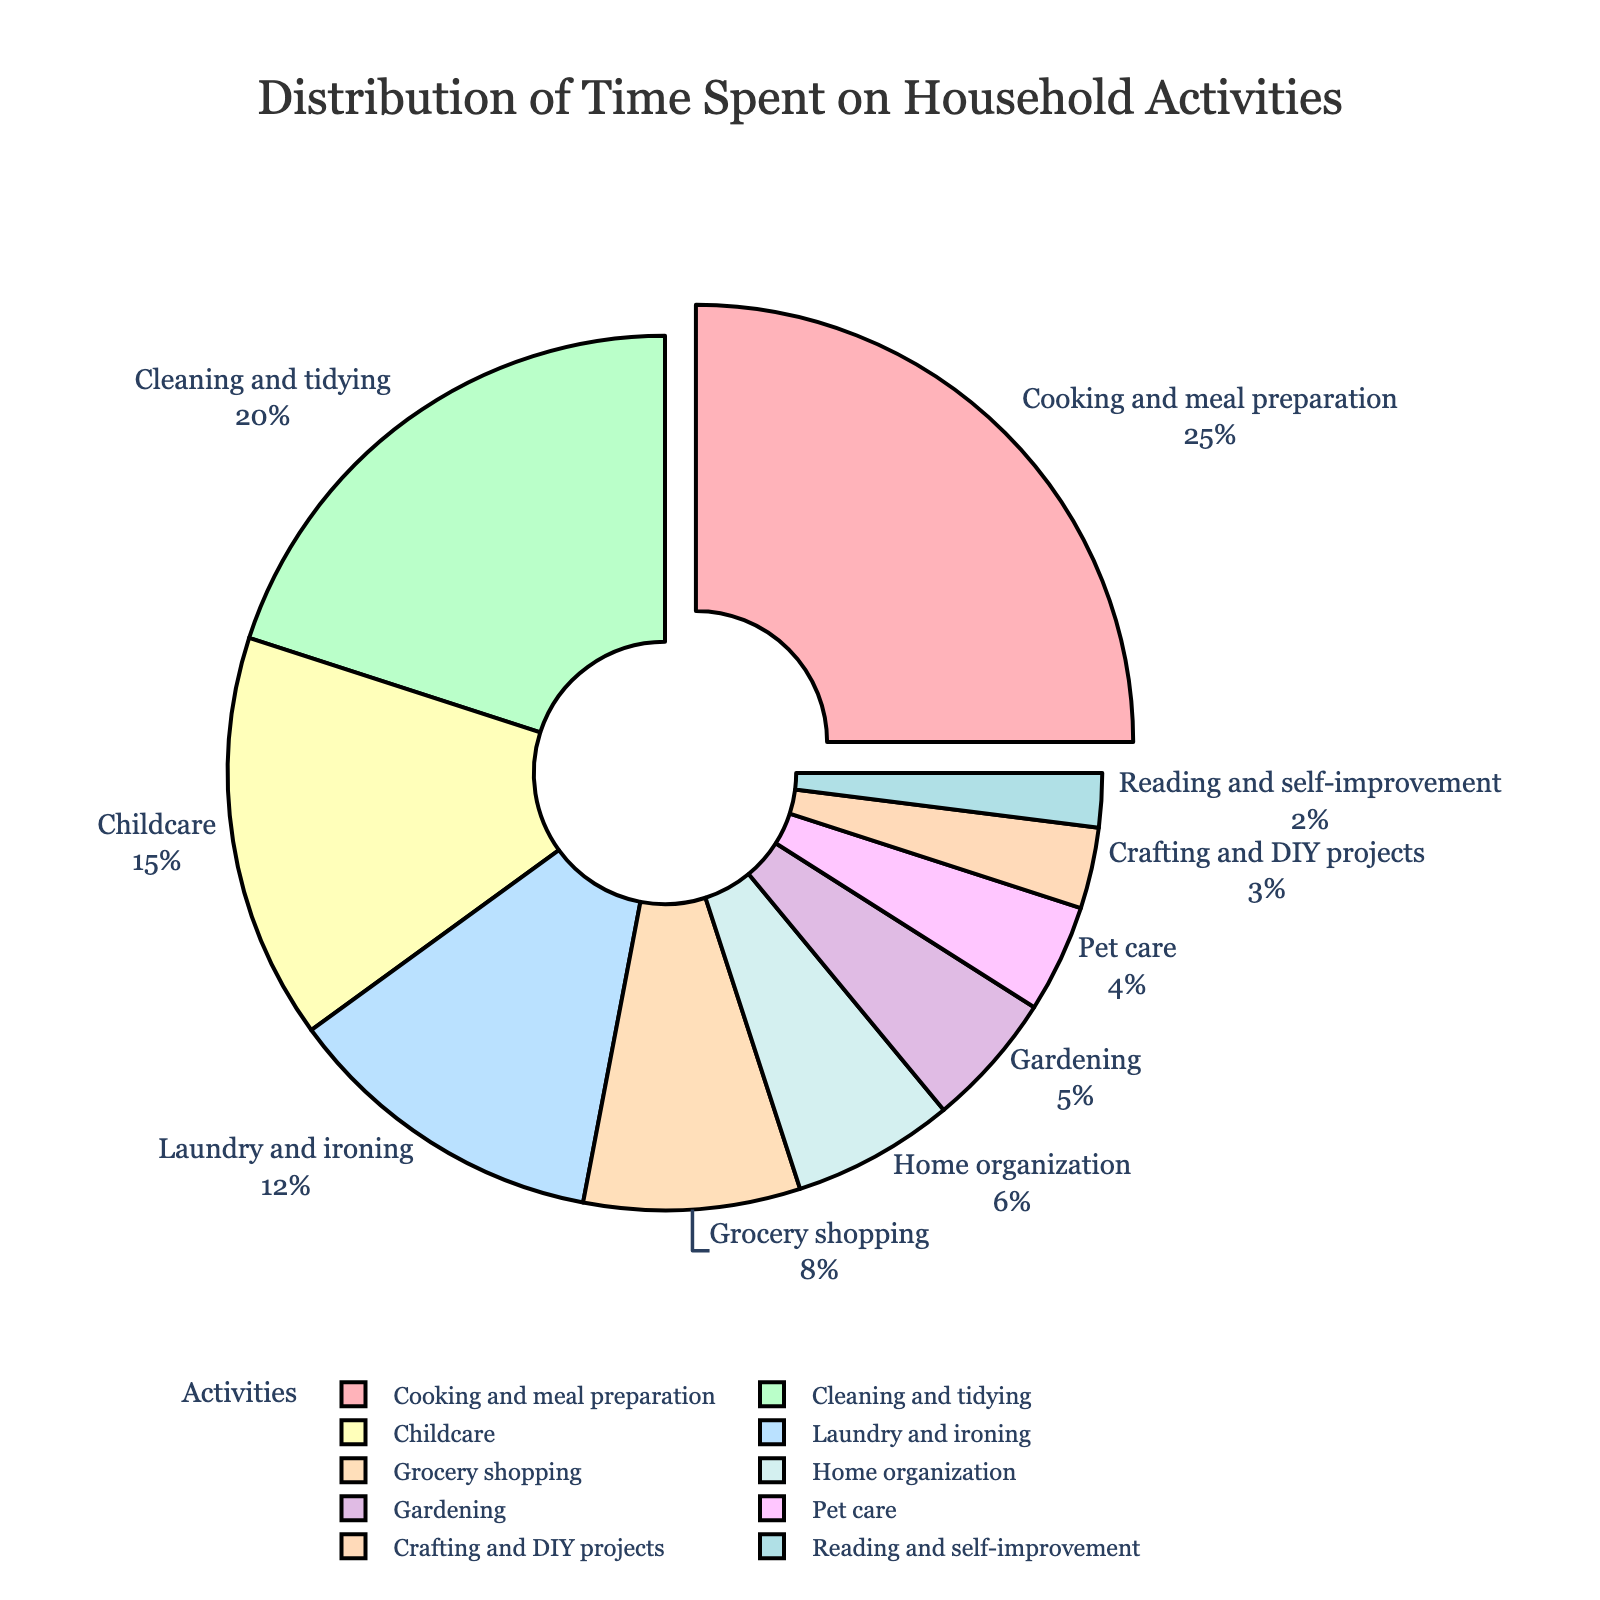Which activity has the highest percentage of time spent? The slice with the largest pulled-out portion represents the activity with the highest percentage of time spent, which is labeled as "Cooking and meal preparation" with 25%.
Answer: Cooking and meal preparation What is the combined percentage of time spent on Cleaning and tidying, and Laundry and ironing? To find the combined percentage, add the percentages of "Cleaning and tidying" (20%) and "Laundry and ironing" (12%): 20% + 12% = 32%.
Answer: 32% How much more time is spent on Childcare compared to Pet care? Find the difference between the percentages of "Childcare" (15%) and "Pet care" (4%): 15% - 4% = 11%.
Answer: 11% Which activity has the least amount of time spent? The smallest slice in the pie chart, labeled "Reading and self-improvement," represents the least amount of time spent with 2%.
Answer: Reading and self-improvement What is the total percentage of time spent on activities related to children and pets (Childcare and Pet care)? Summing up the percentages for "Childcare" (15%) and "Pet care" (4%): 15% + 4% = 19%.
Answer: 19% Compare the time spent on Grocery shopping to that on Gardening. The percentages for "Grocery shopping" (8%) and "Gardening" (5%) show that more time is spent on Grocery shopping.
Answer: Grocery shopping What percentage of time is spent on creative activities (Crafting and DIY projects and Reading and self-improvement)? Add the percentages of "Crafting and DIY projects" (3%) and "Reading and self-improvement" (2%): 3% + 2% = 5%.
Answer: 5% Which two activities combined account for almost one-third of the total time spent? Look for the combination of activities whose percentages sum up to around 33%. The combined percentage of "Cooking and meal preparation" (25%) and "Reading and self-improvement" (2%) is not sufficient (27%). The correct combination is "Cleaning and tidying" (20%) and "Laundry and ironing" (12%) which sums to 32%, close to one-third.
Answer: Cleaning and tidying, Laundry and ironing How does the time spent on Home organization compare with Pet care? Compare their percentages: "Home organization" has 6% and "Pet care" has 4%, indicating more time is spent on Home organization.
Answer: Home organization What is the difference in percentage between the time spent on Cleaning and tidying compared to Gardening? Subtract the percentage of time spent on "Gardening" (5%) from "Cleaning and tidying" (20%): 20% - 5% = 15%.
Answer: 15% 